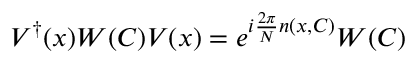<formula> <loc_0><loc_0><loc_500><loc_500>V ^ { \dagger } ( x ) W ( C ) V ( x ) = e ^ { i { \frac { 2 \pi } { N } } n ( x , C ) } W ( C )</formula> 